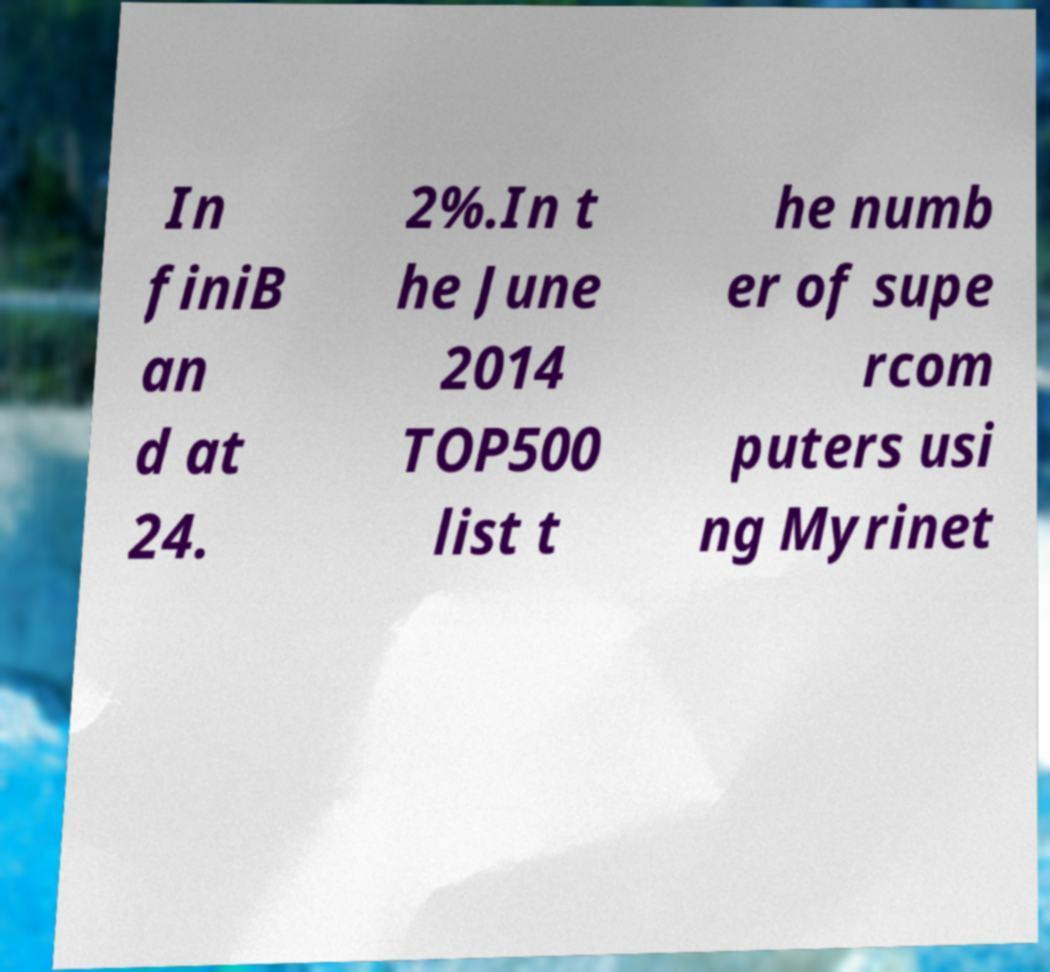Could you extract and type out the text from this image? In finiB an d at 24. 2%.In t he June 2014 TOP500 list t he numb er of supe rcom puters usi ng Myrinet 